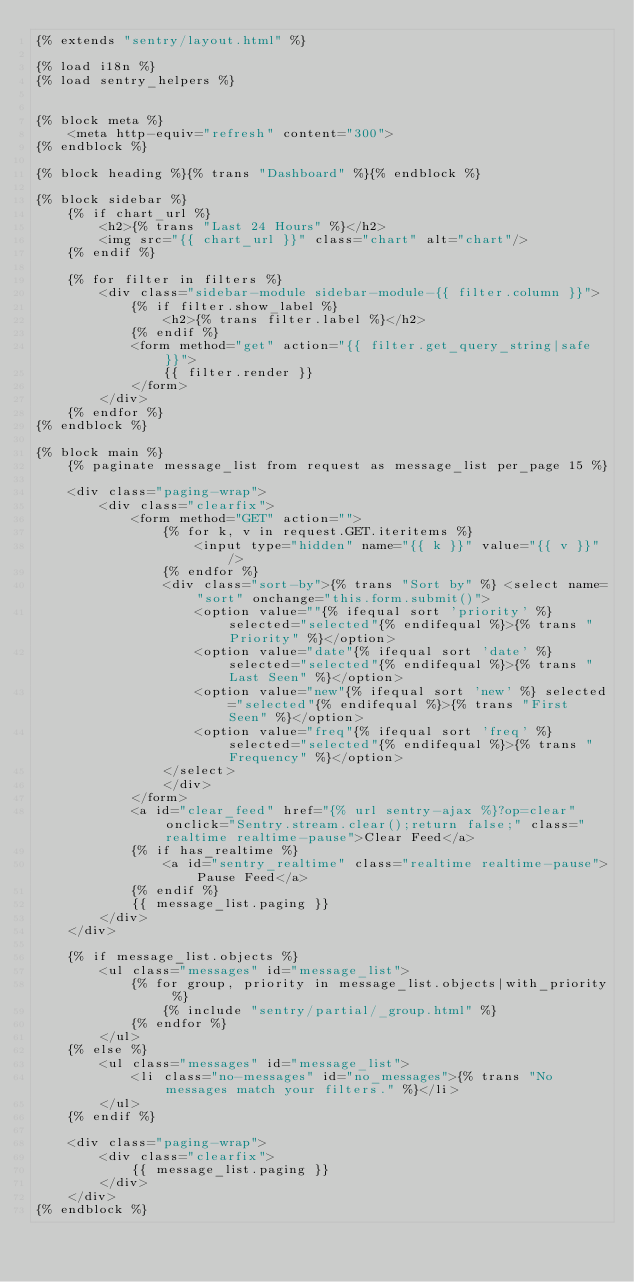Convert code to text. <code><loc_0><loc_0><loc_500><loc_500><_HTML_>{% extends "sentry/layout.html" %}

{% load i18n %}
{% load sentry_helpers %}


{% block meta %}
    <meta http-equiv="refresh" content="300">
{% endblock %}

{% block heading %}{% trans "Dashboard" %}{% endblock %}

{% block sidebar %}
    {% if chart_url %}
        <h2>{% trans "Last 24 Hours" %}</h2>
        <img src="{{ chart_url }}" class="chart" alt="chart"/>
    {% endif %}

    {% for filter in filters %}
        <div class="sidebar-module sidebar-module-{{ filter.column }}">
            {% if filter.show_label %}
                <h2>{% trans filter.label %}</h2>
            {% endif %}
            <form method="get" action="{{ filter.get_query_string|safe }}">
                {{ filter.render }}
            </form>
        </div>
    {% endfor %}
{% endblock %}

{% block main %}
    {% paginate message_list from request as message_list per_page 15 %}

    <div class="paging-wrap">
        <div class="clearfix">
            <form method="GET" action="">
                {% for k, v in request.GET.iteritems %}
                    <input type="hidden" name="{{ k }}" value="{{ v }}"/>
                {% endfor %}
                <div class="sort-by">{% trans "Sort by" %} <select name="sort" onchange="this.form.submit()">
                    <option value=""{% ifequal sort 'priority' %} selected="selected"{% endifequal %}>{% trans "Priority" %}</option>
                    <option value="date"{% ifequal sort 'date' %} selected="selected"{% endifequal %}>{% trans "Last Seen" %}</option>
                    <option value="new"{% ifequal sort 'new' %} selected="selected"{% endifequal %}>{% trans "First Seen" %}</option>
                    <option value="freq"{% ifequal sort 'freq' %} selected="selected"{% endifequal %}>{% trans "Frequency" %}</option>
                </select>
                </div>
            </form>
            <a id="clear_feed" href="{% url sentry-ajax %}?op=clear" onclick="Sentry.stream.clear();return false;" class="realtime realtime-pause">Clear Feed</a>
            {% if has_realtime %}
                <a id="sentry_realtime" class="realtime realtime-pause">Pause Feed</a>
            {% endif %}
            {{ message_list.paging }}
        </div>
    </div>
    
    {% if message_list.objects %}
        <ul class="messages" id="message_list">
            {% for group, priority in message_list.objects|with_priority %}
                {% include "sentry/partial/_group.html" %}
            {% endfor %}
        </ul>
    {% else %}
        <ul class="messages" id="message_list">
            <li class="no-messages" id="no_messages">{% trans "No messages match your filters." %}</li>
        </ul>
    {% endif %}

    <div class="paging-wrap">
        <div class="clearfix">
            {{ message_list.paging }}
        </div>
    </div>
{% endblock %}


</code> 